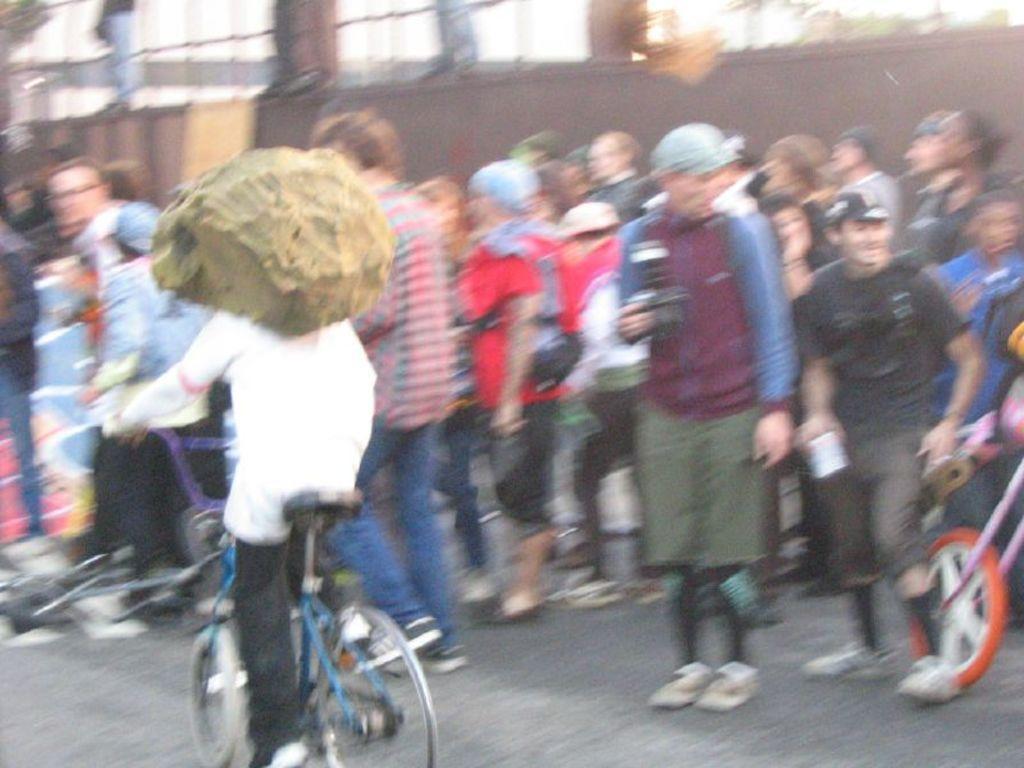How would you summarize this image in a sentence or two? In this image we can see some group of persons standing and there are some persons cycling and in the background of the image there is a wall. 